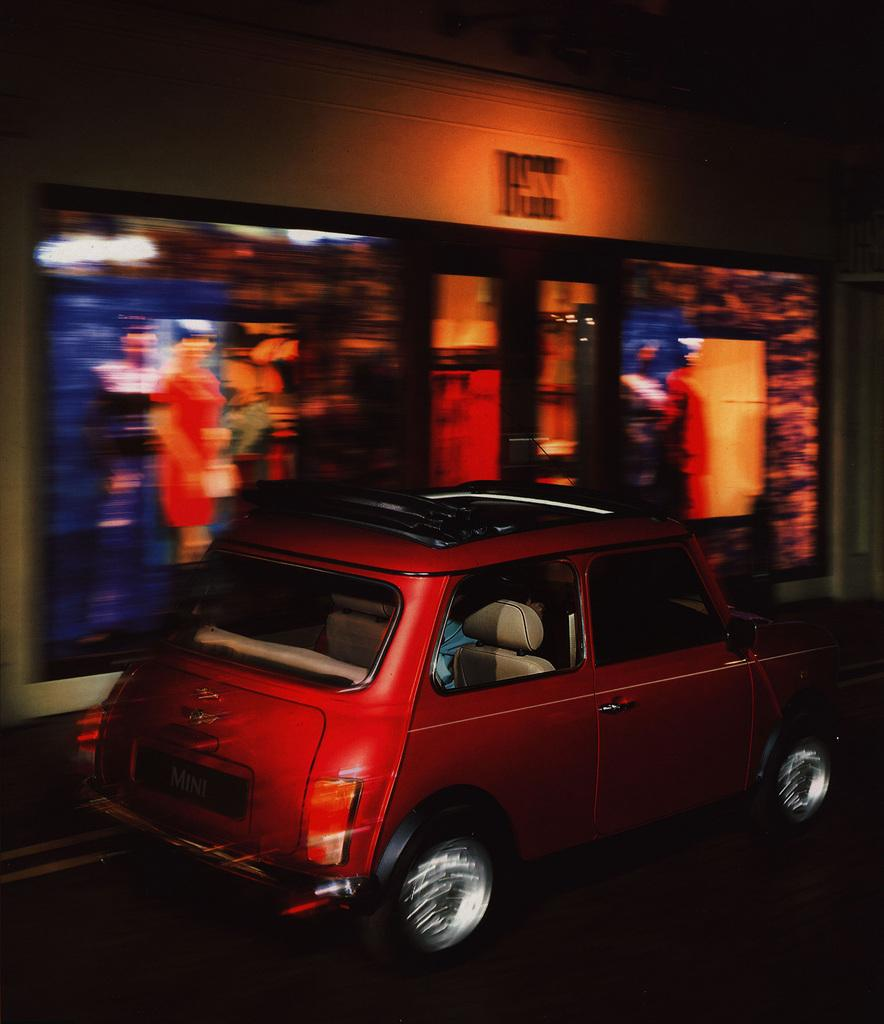What type of vehicle can be seen on the road in the image? There is a red color vehicle on the road in the image. Where is the vehicle located in relation to the hoarding? The vehicle is near a hoarding in the image. What can be seen on the wall in the background of the image? There is a photo frame on the wall in the background of the image. How would you describe the color of the background in the image? The background is dark in color. What type of rice is being cooked in the photo frame in the image? There is no rice or cooking activity present in the image. The photo frame on the wall is not related to any food preparation. 